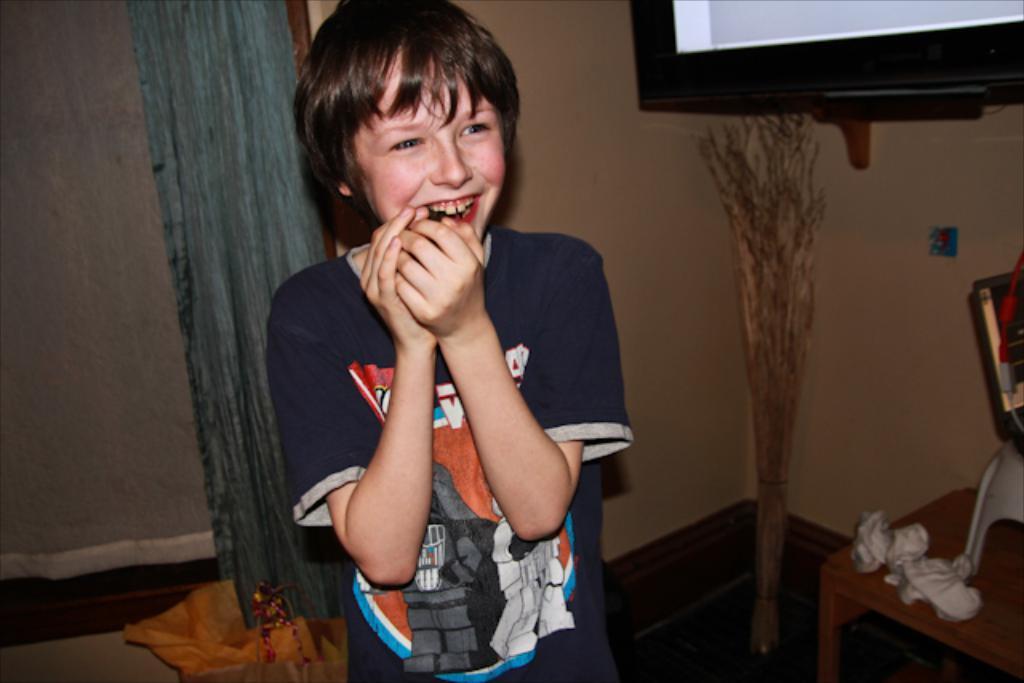Could you give a brief overview of what you see in this image? This is the picture of a boy standing and smiling in the back ground we have a curtain , a blanket , a wooden sticks , table and a television attached to the wall. 